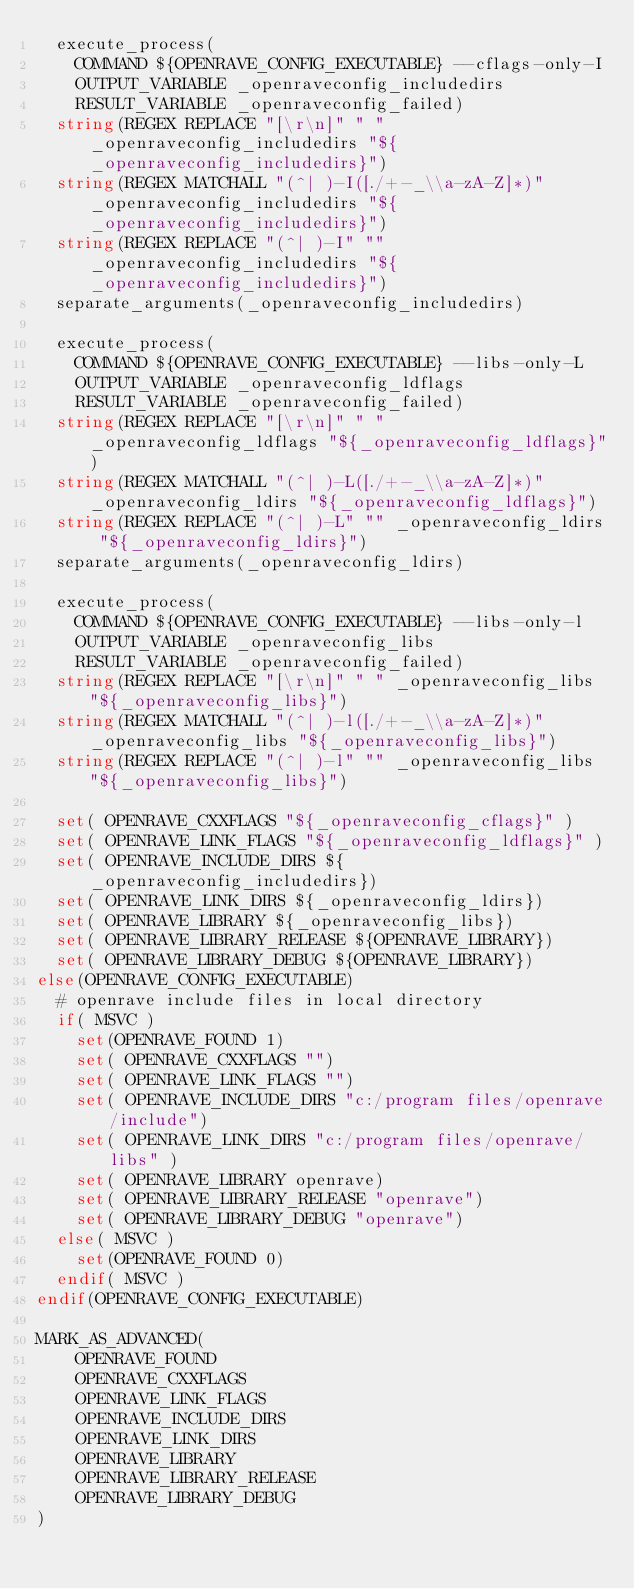<code> <loc_0><loc_0><loc_500><loc_500><_CMake_>  execute_process(
    COMMAND ${OPENRAVE_CONFIG_EXECUTABLE} --cflags-only-I
    OUTPUT_VARIABLE _openraveconfig_includedirs
    RESULT_VARIABLE _openraveconfig_failed)
  string(REGEX REPLACE "[\r\n]" " " _openraveconfig_includedirs "${_openraveconfig_includedirs}")
  string(REGEX MATCHALL "(^| )-I([./+-_\\a-zA-Z]*)" _openraveconfig_includedirs "${_openraveconfig_includedirs}")
  string(REGEX REPLACE "(^| )-I" "" _openraveconfig_includedirs "${_openraveconfig_includedirs}")
  separate_arguments(_openraveconfig_includedirs)

  execute_process(
    COMMAND ${OPENRAVE_CONFIG_EXECUTABLE} --libs-only-L
    OUTPUT_VARIABLE _openraveconfig_ldflags
    RESULT_VARIABLE _openraveconfig_failed)
  string(REGEX REPLACE "[\r\n]" " " _openraveconfig_ldflags "${_openraveconfig_ldflags}")
  string(REGEX MATCHALL "(^| )-L([./+-_\\a-zA-Z]*)" _openraveconfig_ldirs "${_openraveconfig_ldflags}")
  string(REGEX REPLACE "(^| )-L" "" _openraveconfig_ldirs "${_openraveconfig_ldirs}")
  separate_arguments(_openraveconfig_ldirs)

  execute_process(
    COMMAND ${OPENRAVE_CONFIG_EXECUTABLE} --libs-only-l
    OUTPUT_VARIABLE _openraveconfig_libs
    RESULT_VARIABLE _openraveconfig_failed)
  string(REGEX REPLACE "[\r\n]" " " _openraveconfig_libs "${_openraveconfig_libs}")
  string(REGEX MATCHALL "(^| )-l([./+-_\\a-zA-Z]*)" _openraveconfig_libs "${_openraveconfig_libs}")
  string(REGEX REPLACE "(^| )-l" "" _openraveconfig_libs "${_openraveconfig_libs}")  

  set( OPENRAVE_CXXFLAGS "${_openraveconfig_cflags}" )
  set( OPENRAVE_LINK_FLAGS "${_openraveconfig_ldflags}" )
  set( OPENRAVE_INCLUDE_DIRS ${_openraveconfig_includedirs})
  set( OPENRAVE_LINK_DIRS ${_openraveconfig_ldirs})
  set( OPENRAVE_LIBRARY ${_openraveconfig_libs})
  set( OPENRAVE_LIBRARY_RELEASE ${OPENRAVE_LIBRARY})
  set( OPENRAVE_LIBRARY_DEBUG ${OPENRAVE_LIBRARY})
else(OPENRAVE_CONFIG_EXECUTABLE)
  # openrave include files in local directory
  if( MSVC )
    set(OPENRAVE_FOUND 1)
    set( OPENRAVE_CXXFLAGS "")
    set( OPENRAVE_LINK_FLAGS "")
    set( OPENRAVE_INCLUDE_DIRS "c:/program files/openrave/include")
    set( OPENRAVE_LINK_DIRS "c:/program files/openrave/libs" )
    set( OPENRAVE_LIBRARY openrave)
    set( OPENRAVE_LIBRARY_RELEASE "openrave")
    set( OPENRAVE_LIBRARY_DEBUG "openrave")
  else( MSVC )
    set(OPENRAVE_FOUND 0)
  endif( MSVC )  
endif(OPENRAVE_CONFIG_EXECUTABLE)

MARK_AS_ADVANCED(
    OPENRAVE_FOUND
    OPENRAVE_CXXFLAGS
    OPENRAVE_LINK_FLAGS
    OPENRAVE_INCLUDE_DIRS
    OPENRAVE_LINK_DIRS
    OPENRAVE_LIBRARY
    OPENRAVE_LIBRARY_RELEASE
    OPENRAVE_LIBRARY_DEBUG
)
</code> 